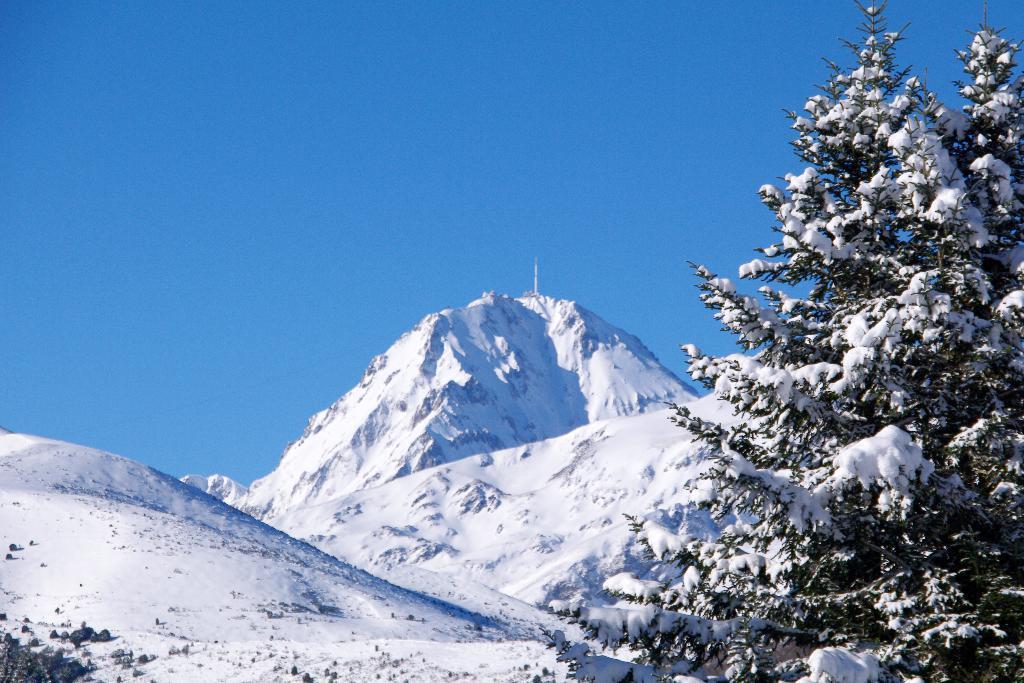Could you give a brief overview of what you see in this image? In this image I can see mountains,trees and snow. The sky is in blue color. 